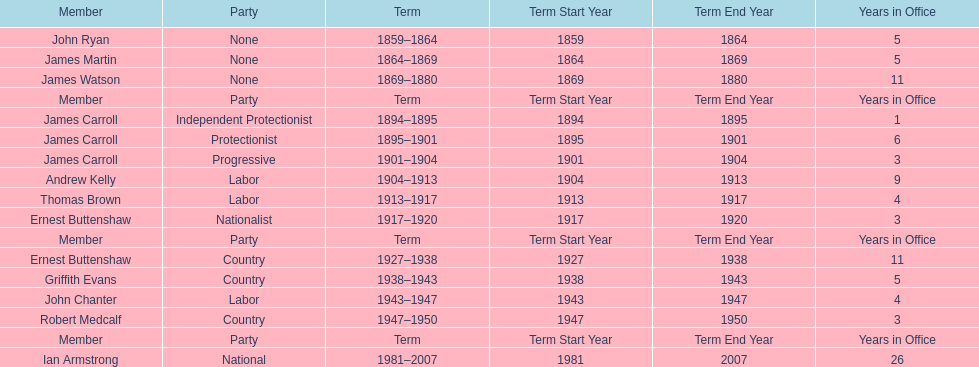How many years of service do the members of the second incarnation have combined? 26. 